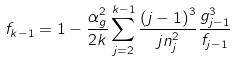<formula> <loc_0><loc_0><loc_500><loc_500>f _ { k - 1 } = 1 - \frac { \alpha _ { g } ^ { 2 } } { 2 k } \sum _ { j = 2 } ^ { k - 1 } \frac { \left ( j - 1 \right ) ^ { 3 } } { j n _ { j } ^ { 2 } } \frac { g _ { j - 1 } ^ { 3 } } { f _ { j - 1 } }</formula> 